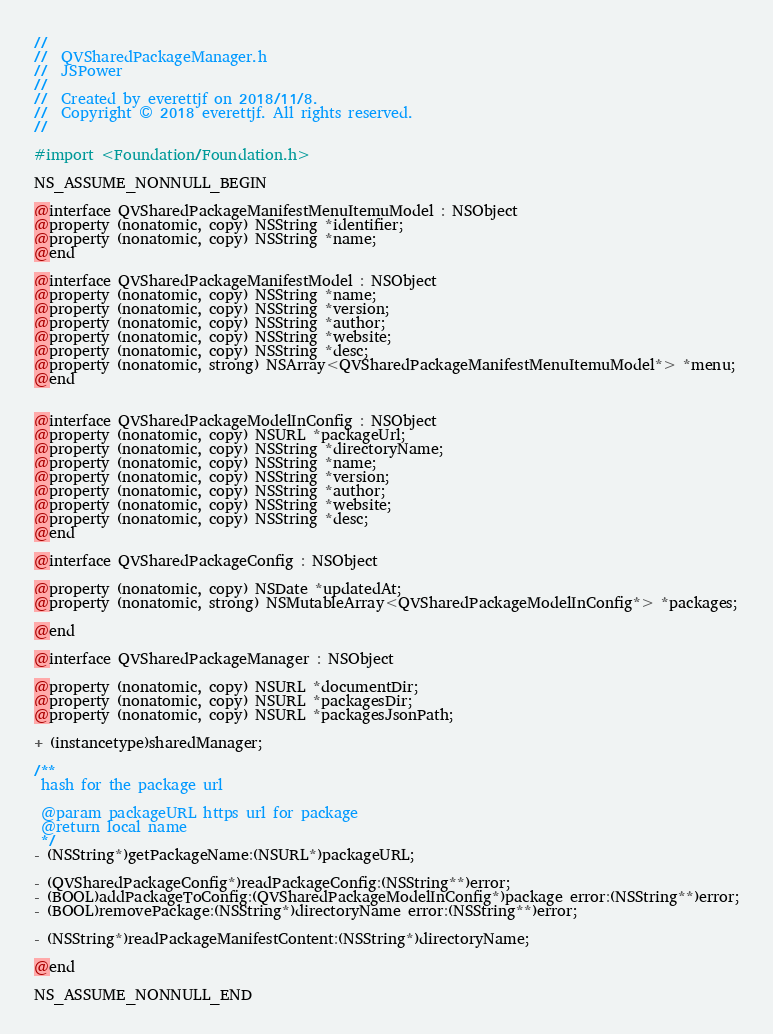<code> <loc_0><loc_0><loc_500><loc_500><_C_>//
//  QVSharedPackageManager.h
//  JSPower
//
//  Created by everettjf on 2018/11/8.
//  Copyright © 2018 everettjf. All rights reserved.
//

#import <Foundation/Foundation.h>

NS_ASSUME_NONNULL_BEGIN

@interface QVSharedPackageManifestMenuItemuModel : NSObject
@property (nonatomic, copy) NSString *identifier;
@property (nonatomic, copy) NSString *name;
@end

@interface QVSharedPackageManifestModel : NSObject
@property (nonatomic, copy) NSString *name;
@property (nonatomic, copy) NSString *version;
@property (nonatomic, copy) NSString *author;
@property (nonatomic, copy) NSString *website;
@property (nonatomic, copy) NSString *desc;
@property (nonatomic, strong) NSArray<QVSharedPackageManifestMenuItemuModel*> *menu;
@end


@interface QVSharedPackageModelInConfig : NSObject
@property (nonatomic, copy) NSURL *packageUrl;
@property (nonatomic, copy) NSString *directoryName;
@property (nonatomic, copy) NSString *name;
@property (nonatomic, copy) NSString *version;
@property (nonatomic, copy) NSString *author;
@property (nonatomic, copy) NSString *website;
@property (nonatomic, copy) NSString *desc;
@end

@interface QVSharedPackageConfig : NSObject

@property (nonatomic, copy) NSDate *updatedAt;
@property (nonatomic, strong) NSMutableArray<QVSharedPackageModelInConfig*> *packages;

@end

@interface QVSharedPackageManager : NSObject

@property (nonatomic, copy) NSURL *documentDir;
@property (nonatomic, copy) NSURL *packagesDir;
@property (nonatomic, copy) NSURL *packagesJsonPath;

+ (instancetype)sharedManager;

/**
 hash for the package url

 @param packageURL https url for package
 @return local name
 */
- (NSString*)getPackageName:(NSURL*)packageURL;

- (QVSharedPackageConfig*)readPackageConfig:(NSString**)error;
- (BOOL)addPackageToConfig:(QVSharedPackageModelInConfig*)package error:(NSString**)error;
- (BOOL)removePackage:(NSString*)directoryName error:(NSString**)error;

- (NSString*)readPackageManifestContent:(NSString*)directoryName;

@end

NS_ASSUME_NONNULL_END
</code> 